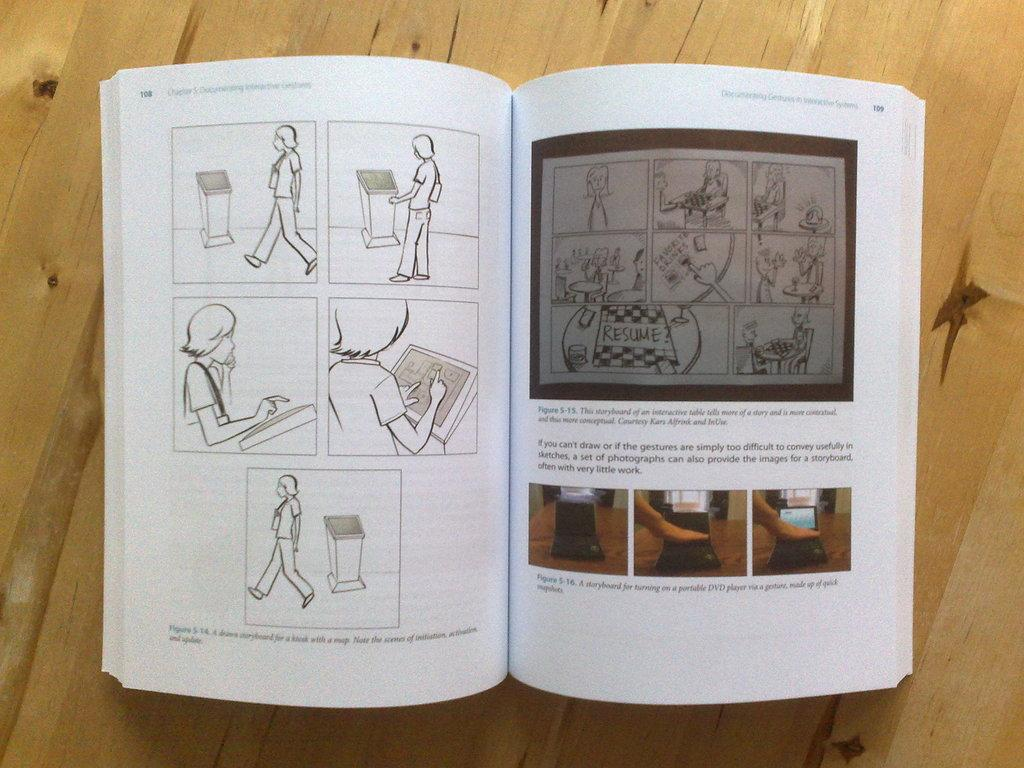<image>
Relay a brief, clear account of the picture shown. a book that has the word simply on the 2nd page 